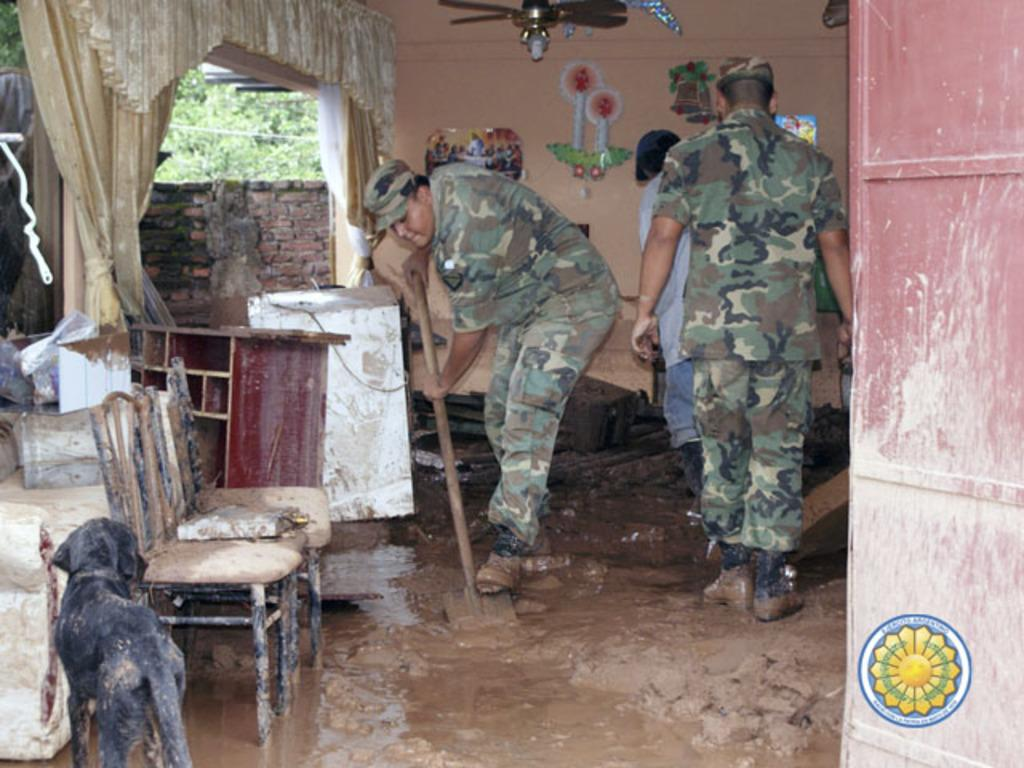What are the people in the image doing? The persons in the image are standing in the mud. What object can be seen in the image that is typically used for sitting? There is a chair in the image. What type of animal is present in the image? There is a dog in the image. What can be seen in the background of the image? There is a wall and trees visible in the background. What device is present in the image that is used for cooling? There is a fan in the image. What type of string is the dog playing with in the image? There is no string present in the image; the dog is not playing with any object. What type of work are the people doing in the image? The provided facts do not mention any work being done by the people in the image. 